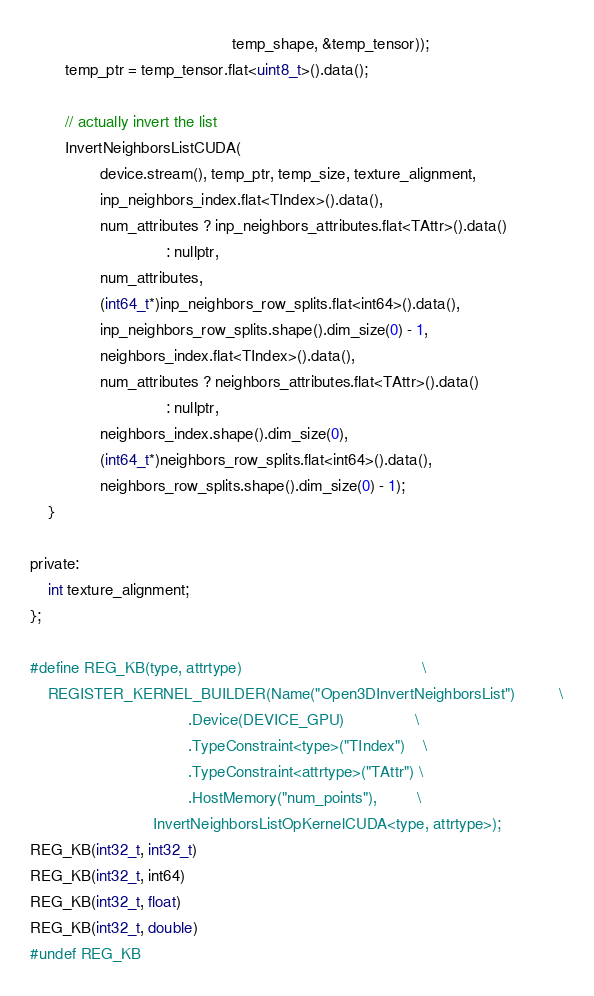<code> <loc_0><loc_0><loc_500><loc_500><_Cuda_>                                              temp_shape, &temp_tensor));
        temp_ptr = temp_tensor.flat<uint8_t>().data();

        // actually invert the list
        InvertNeighborsListCUDA(
                device.stream(), temp_ptr, temp_size, texture_alignment,
                inp_neighbors_index.flat<TIndex>().data(),
                num_attributes ? inp_neighbors_attributes.flat<TAttr>().data()
                               : nullptr,
                num_attributes,
                (int64_t*)inp_neighbors_row_splits.flat<int64>().data(),
                inp_neighbors_row_splits.shape().dim_size(0) - 1,
                neighbors_index.flat<TIndex>().data(),
                num_attributes ? neighbors_attributes.flat<TAttr>().data()
                               : nullptr,
                neighbors_index.shape().dim_size(0),
                (int64_t*)neighbors_row_splits.flat<int64>().data(),
                neighbors_row_splits.shape().dim_size(0) - 1);
    }

private:
    int texture_alignment;
};

#define REG_KB(type, attrtype)                                         \
    REGISTER_KERNEL_BUILDER(Name("Open3DInvertNeighborsList")          \
                                    .Device(DEVICE_GPU)                \
                                    .TypeConstraint<type>("TIndex")    \
                                    .TypeConstraint<attrtype>("TAttr") \
                                    .HostMemory("num_points"),         \
                            InvertNeighborsListOpKernelCUDA<type, attrtype>);
REG_KB(int32_t, int32_t)
REG_KB(int32_t, int64)
REG_KB(int32_t, float)
REG_KB(int32_t, double)
#undef REG_KB
</code> 